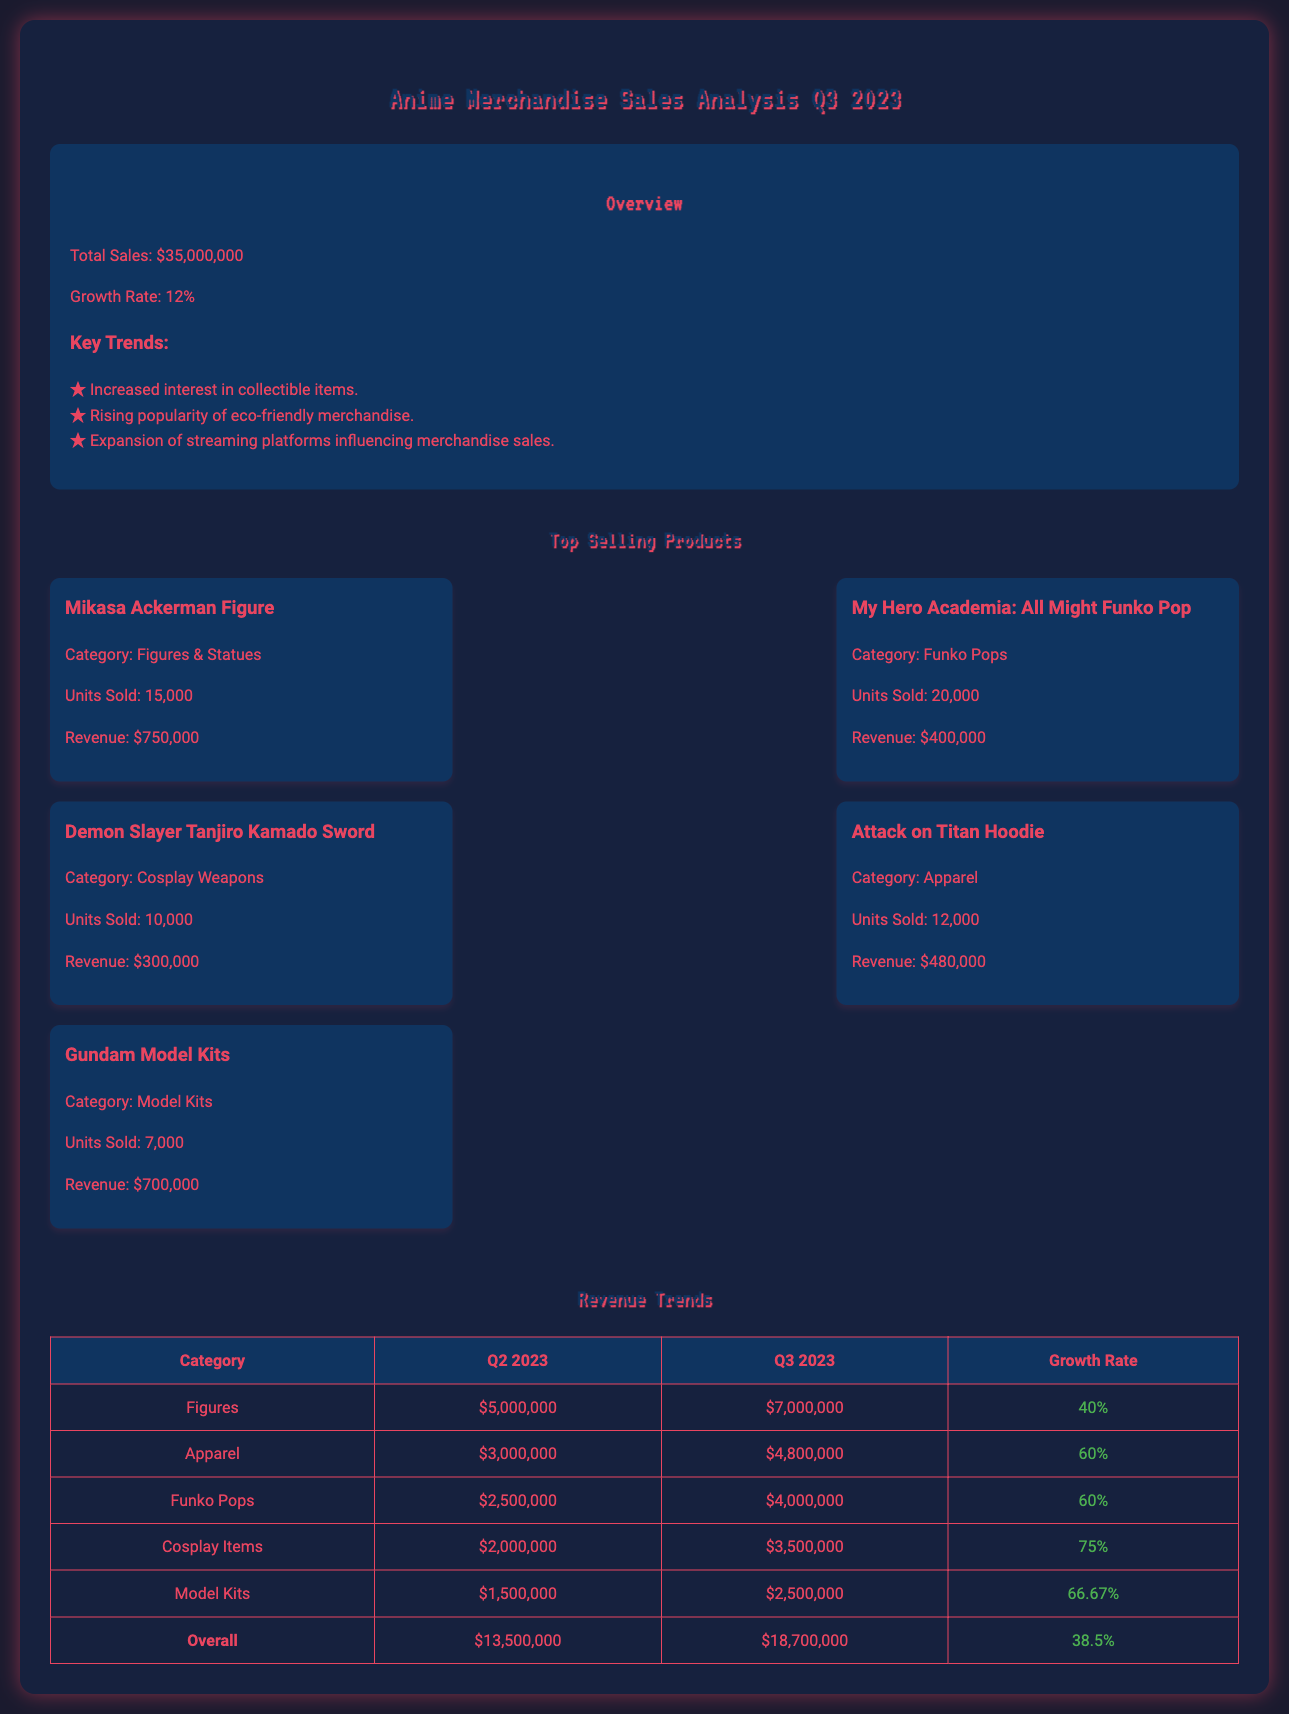What is the total sales for Q3 2023? The total sales is the sum of all revenue, which is stated as $35,000,000 in the document.
Answer: $35,000,000 What was the growth rate in Q3 2023? The growth rate is presented as a percentage increase, specifically mentioned as 12%.
Answer: 12% Which product sold the most units? The document indicates the Mikasa Ackerman Figure sold 15,000 units, which is the highest among the listed products.
Answer: Mikasa Ackerman Figure What is the revenue for the My Hero Academia: All Might Funko Pop? The revenue for this specific product is mentioned as $400,000 in the analysis.
Answer: $400,000 What category had the highest growth rate in Q3 2023? The category of Cosplay Items shows the highest growth rate, indicated as 75%.
Answer: 75% How much revenue did the Figures category generate in Q3 2023? The revenue for the Figures category for Q3 2023 is explicitly stated as $7,000,000 in the table.
Answer: $7,000,000 Which apparel item is listed in the top products? The document mentions the Attack on Titan Hoodie as one of the top-selling apparel items.
Answer: Attack on Titan Hoodie What was the overall revenue for Q2 2023? The overall revenue for Q2 2023 is provided as $13,500,000 in the comparative table.
Answer: $13,500,000 How many units of Gundam Model Kits were sold? The document specifies that 7,000 units of Gundam Model Kits were sold.
Answer: 7,000 